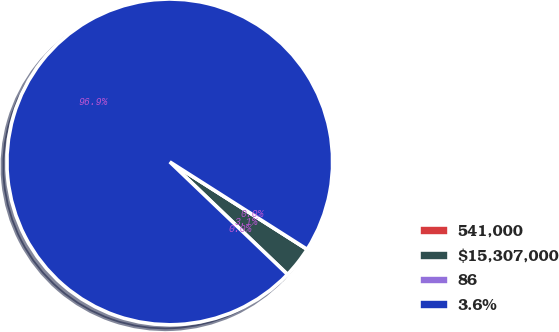Convert chart to OTSL. <chart><loc_0><loc_0><loc_500><loc_500><pie_chart><fcel>541,000<fcel>$15,307,000<fcel>86<fcel>3.6%<nl><fcel>0.0%<fcel>3.12%<fcel>0.0%<fcel>96.88%<nl></chart> 